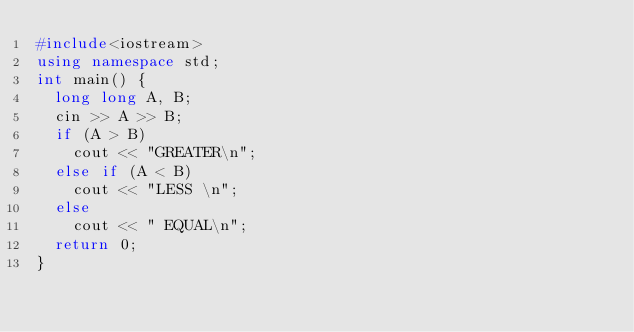Convert code to text. <code><loc_0><loc_0><loc_500><loc_500><_C++_>#include<iostream>
using namespace std;
int main() {
	long long A, B;
	cin >> A >> B;
	if (A > B)
		cout << "GREATER\n";
	else if (A < B)
		cout << "LESS \n";
	else
		cout << " EQUAL\n";
	return 0;
}</code> 